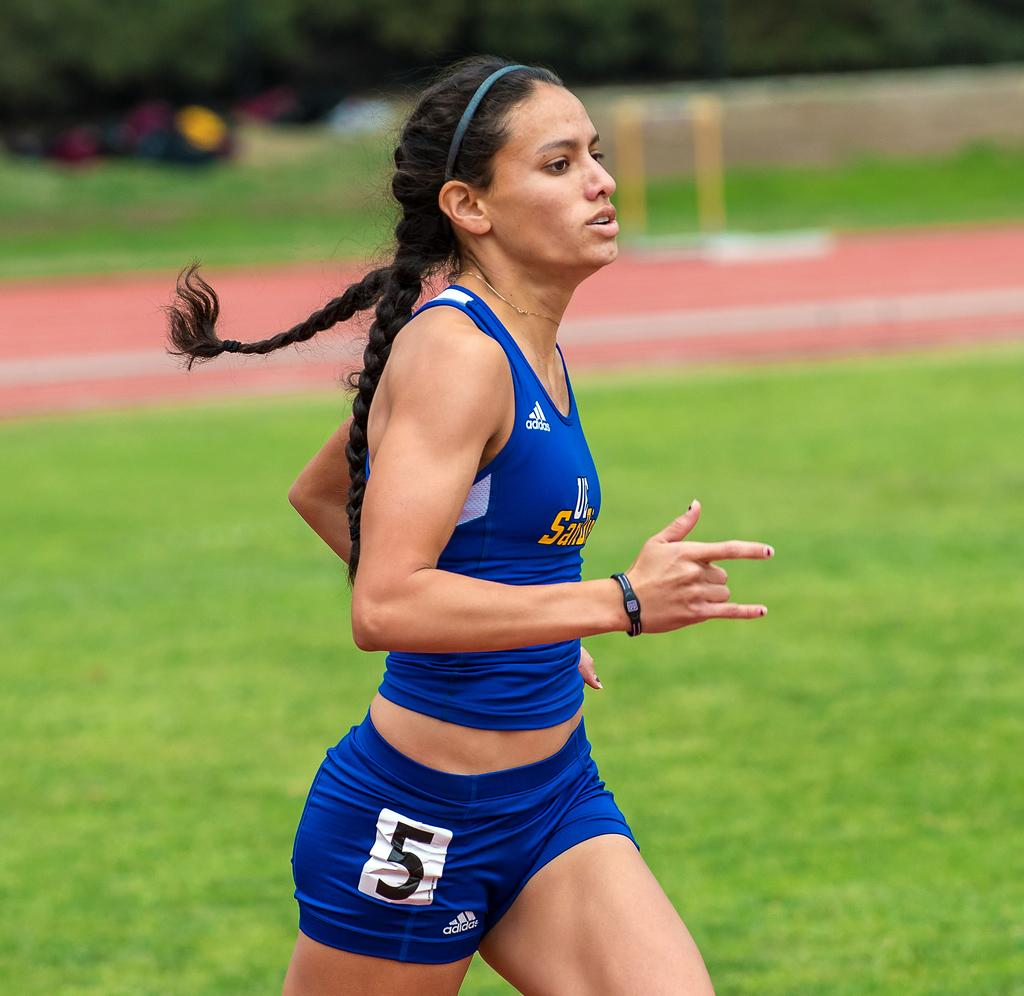Provide a one-sentence caption for the provided image. A femal runner dressed in blue top and shorts carrying the number 5 is seen running by close up. 